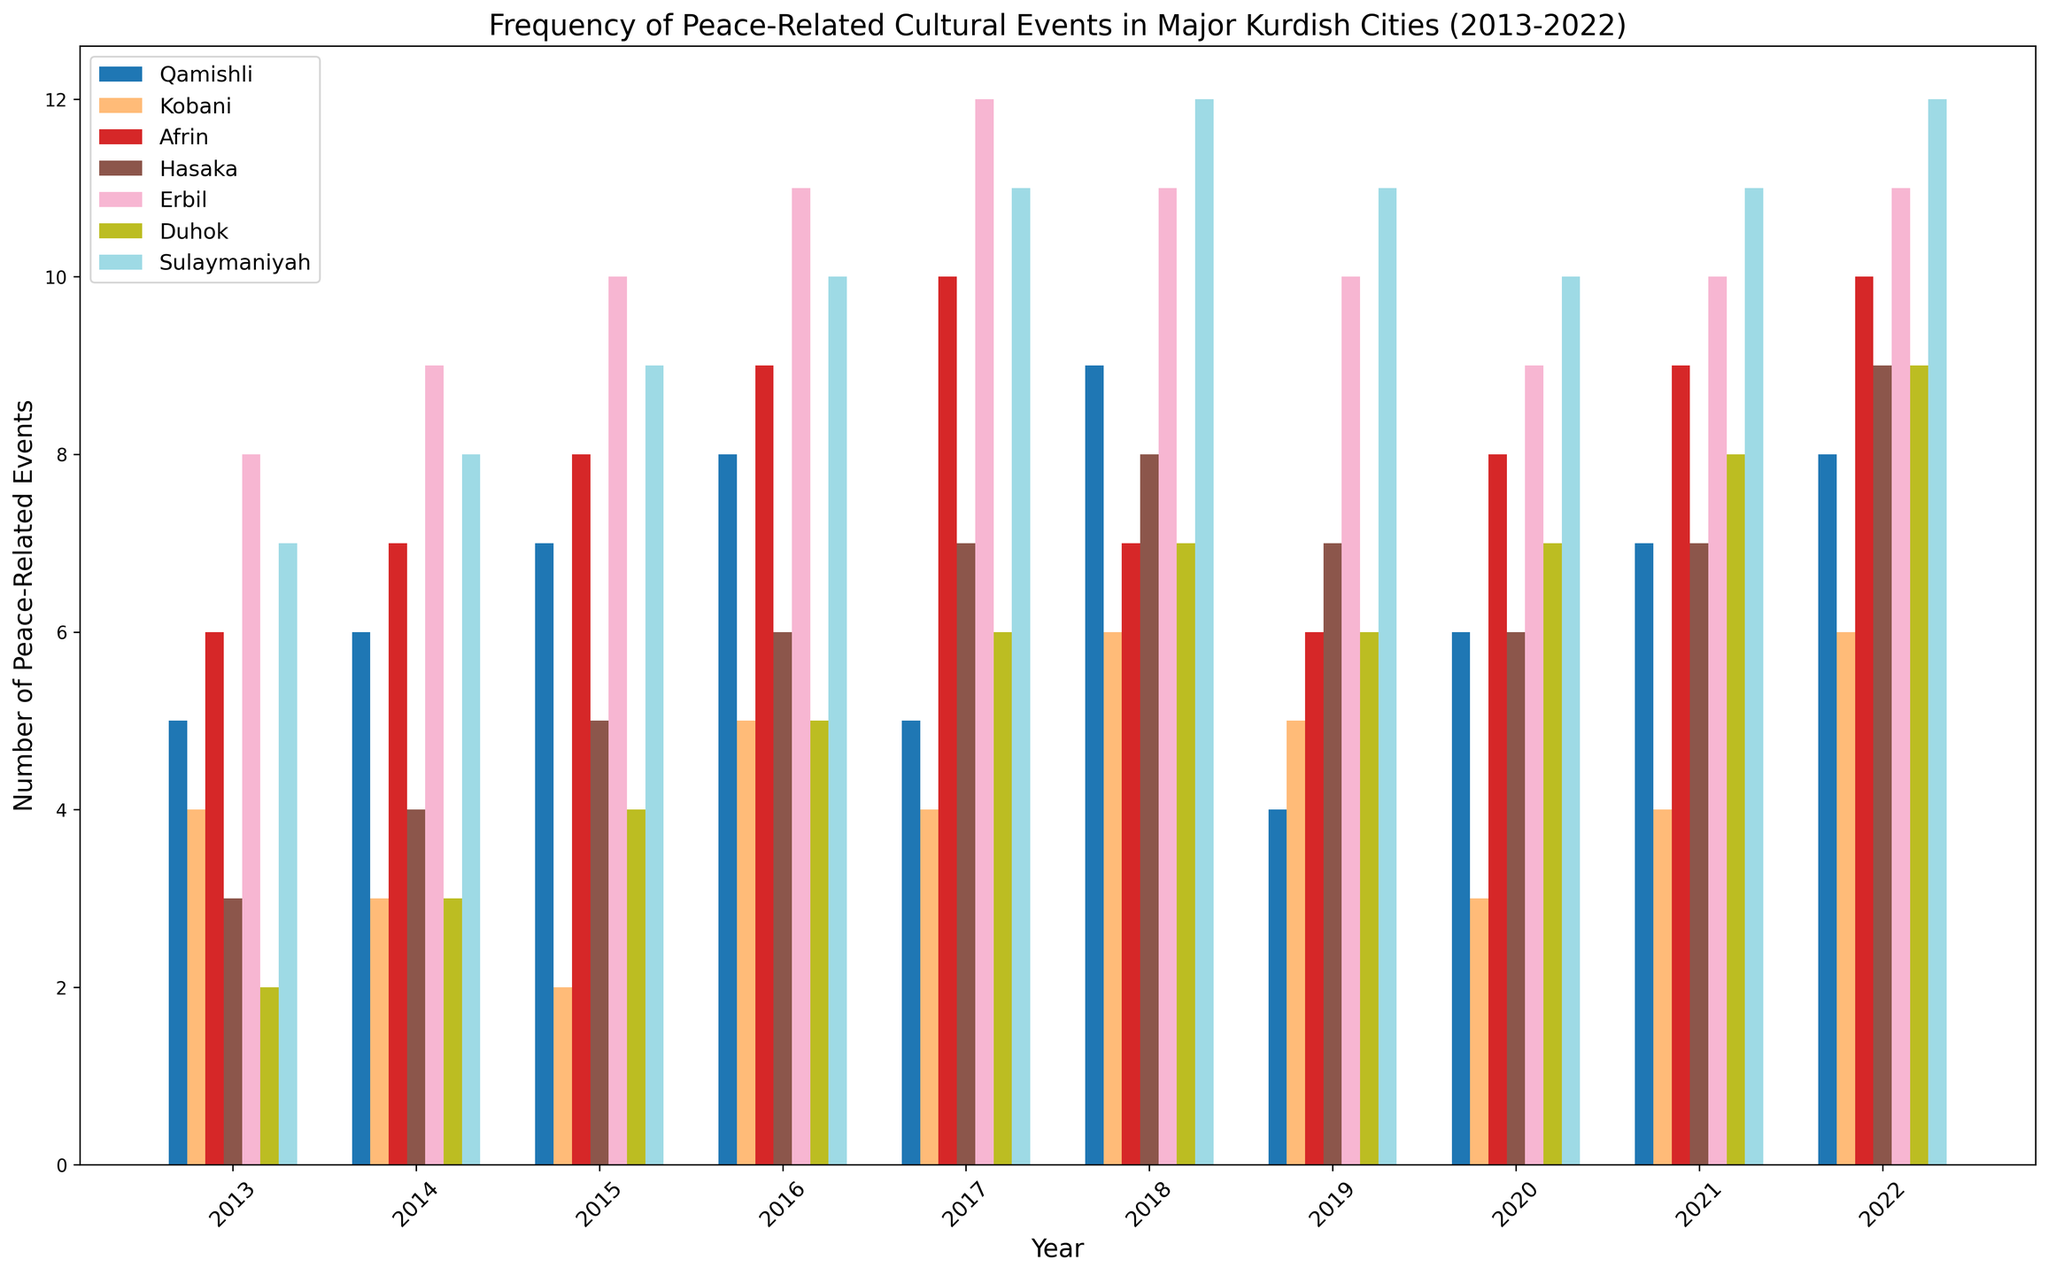What's the trend of peace-related events in Afrin from 2013 to 2022? To identify the trend, look at the bars representing Afrin from 2013 to 2022. Note how the number of events generally increases from 6 in 2013 to a peak of 10 in 2017, dips slightly, and then again reaches 10 in 2022. This shows a generally increasing trend.
Answer: Increasing Which city had the highest number of peace-related events in 2019? Compare the heights of the bars for each city in the year 2019. Afrin, Erbil, and Sulaymaniyah all have bars reaching the highest point, indicating 10 events each.
Answer: Afrin, Erbil, Sulaymaniyah How does the number of peace-related events in Qamishli in 2015 compare to those in Hasaka and Duhok in the same year? Find the bar heights for Qamishli, Hasaka, and Duhok in 2015. Qamishli has 7 events, Hasaka has 5, and Duhok has 4. So, Qamishli had more events than both Hasaka and Duhok.
Answer: Qamishli has more What's the average number of peace-related events in Sulaymaniyah over the decade from 2013 to 2022? Sum the number of events in Sulaymaniyah from 2013 to 2022 and divide by 10. The sum is 91 (7+8+9+10+11+12+11+10+11+12). So, the average is 91/10 = 9.1.
Answer: 9.1 Which city experienced the most significant increase in peace-related events from 2019 to 2020? Look at the difference in bar heights from 2019 to 2020 for each city. Afrin's bars go from 6 to 8, Qamishli's from 4 to 6, Hasaka's from 7 to 6, Erbil's from 10 to 9, Duhok's from 6 to 7, and Sulaymaniyah's from 11 to 10. Both Afrin and Qamishli increased by 2 events, which is the highest.
Answer: Afrin, Qamishli In which years did Erbil have the same number of peace-related events? Find the years where the bar heights are equal for Erbil. Erbil had 10 events in 2015 and 2021, and 11 events in 2016 and 2022.
Answer: 2015 & 2021, 2016 & 2022 What is the difference in the number of peace-related events between Hasaka in 2018 and Kobani in 2022? Look at the bar heights for Hasaka in 2018 and Kobani in 2022. Hasaka had 8 events in 2018, and Kobani had 6 events in 2022. The difference is 8 - 6 = 2.
Answer: 2 From 2013 to 2022, which city had the most fluctuation in the number of peace-related events? To identify fluctuation, look at the variance in bar heights for each city over the years. Qamishli shows the most fluctuation with numbers varying up and down between 4 and 9 across the decade.
Answer: Qamishli 